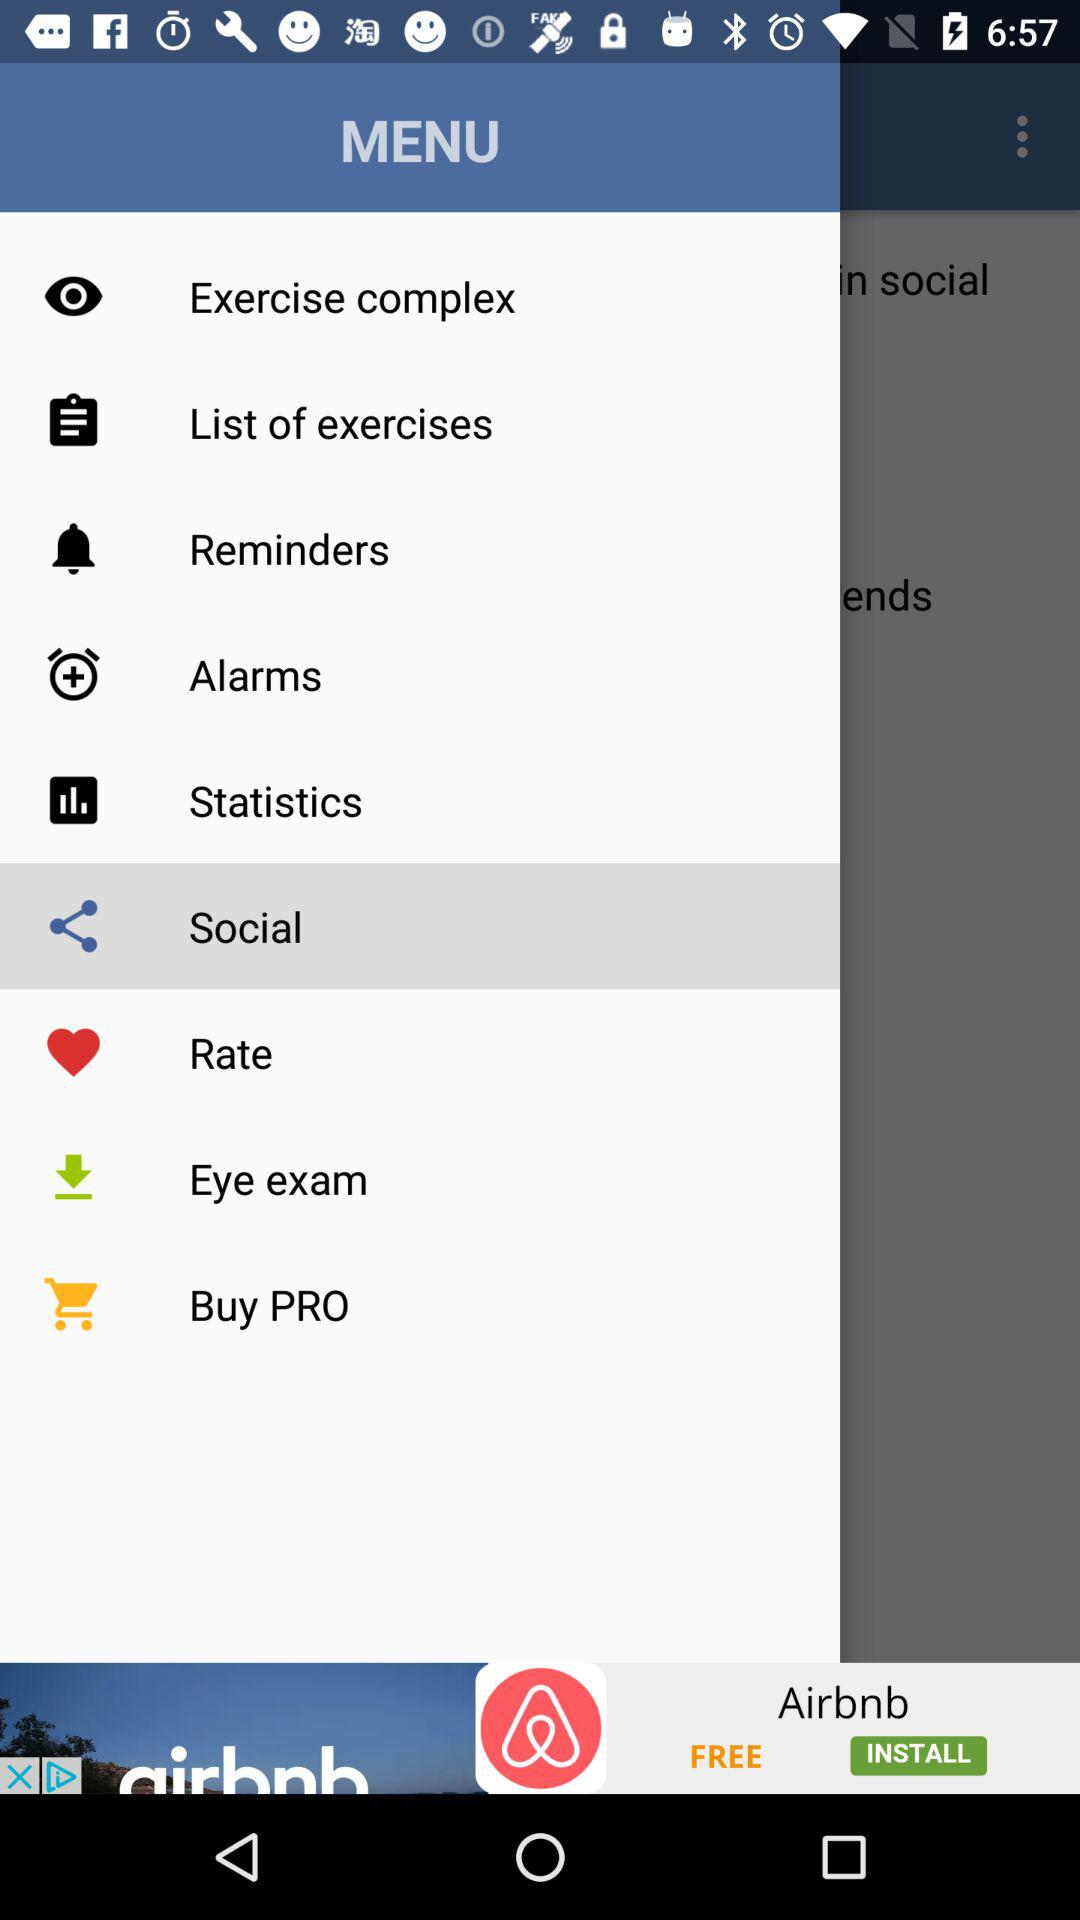Which option is selected? The selected option is "Social". 